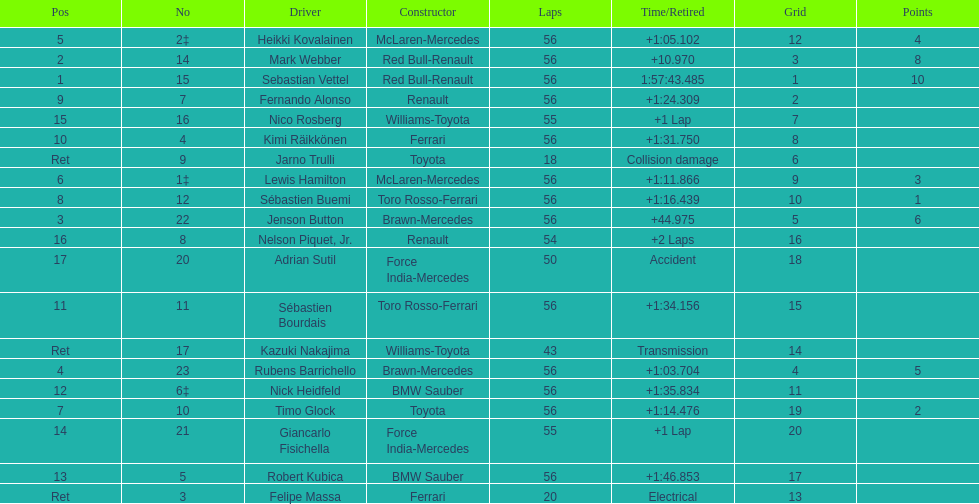Who was the slowest driver to finish the race? Robert Kubica. 